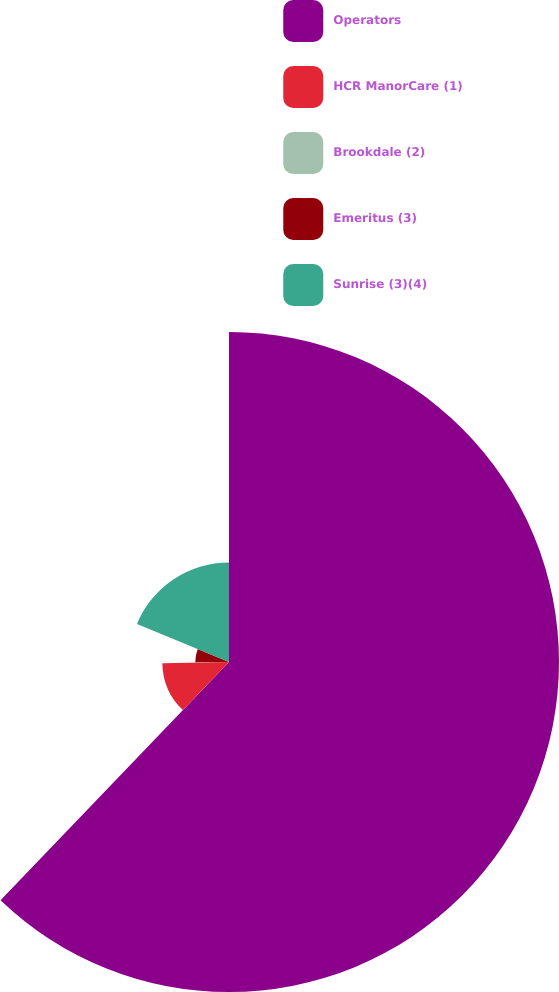Convert chart to OTSL. <chart><loc_0><loc_0><loc_500><loc_500><pie_chart><fcel>Operators<fcel>HCR ManorCare (1)<fcel>Brookdale (2)<fcel>Emeritus (3)<fcel>Sunrise (3)(4)<nl><fcel>62.17%<fcel>12.56%<fcel>0.15%<fcel>6.36%<fcel>18.76%<nl></chart> 